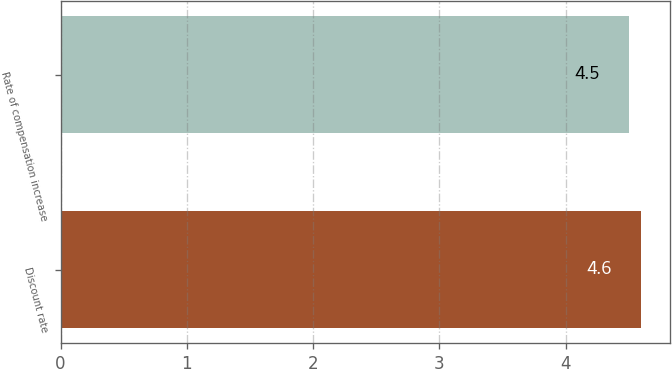Convert chart to OTSL. <chart><loc_0><loc_0><loc_500><loc_500><bar_chart><fcel>Discount rate<fcel>Rate of compensation increase<nl><fcel>4.6<fcel>4.5<nl></chart> 